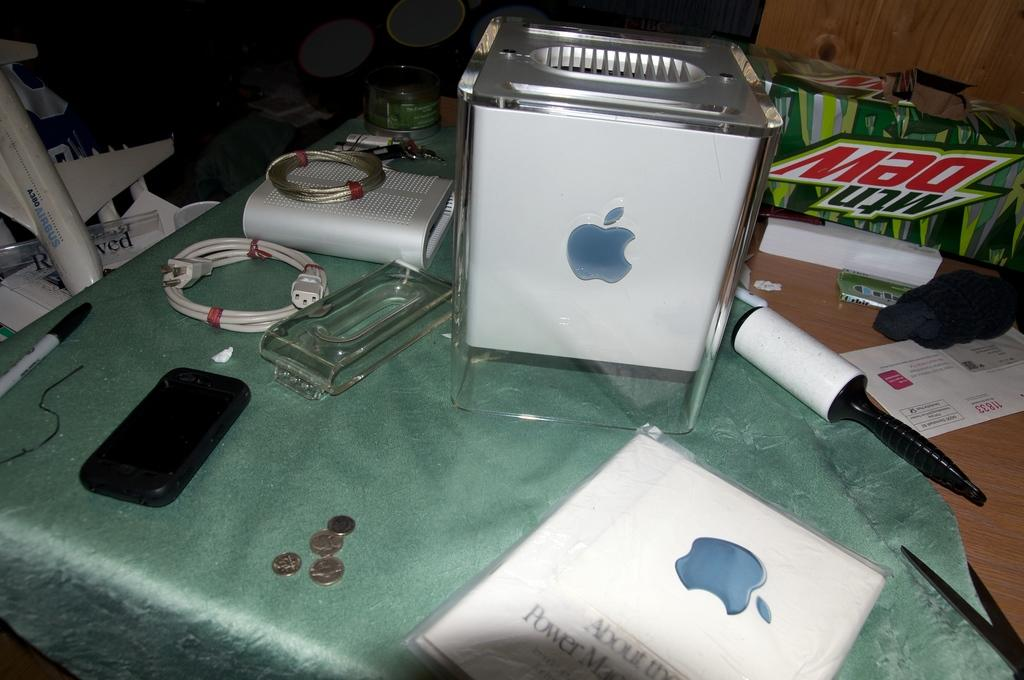Provide a one-sentence caption for the provided image. a mtn dew box behind a box with an apple logo on it. 